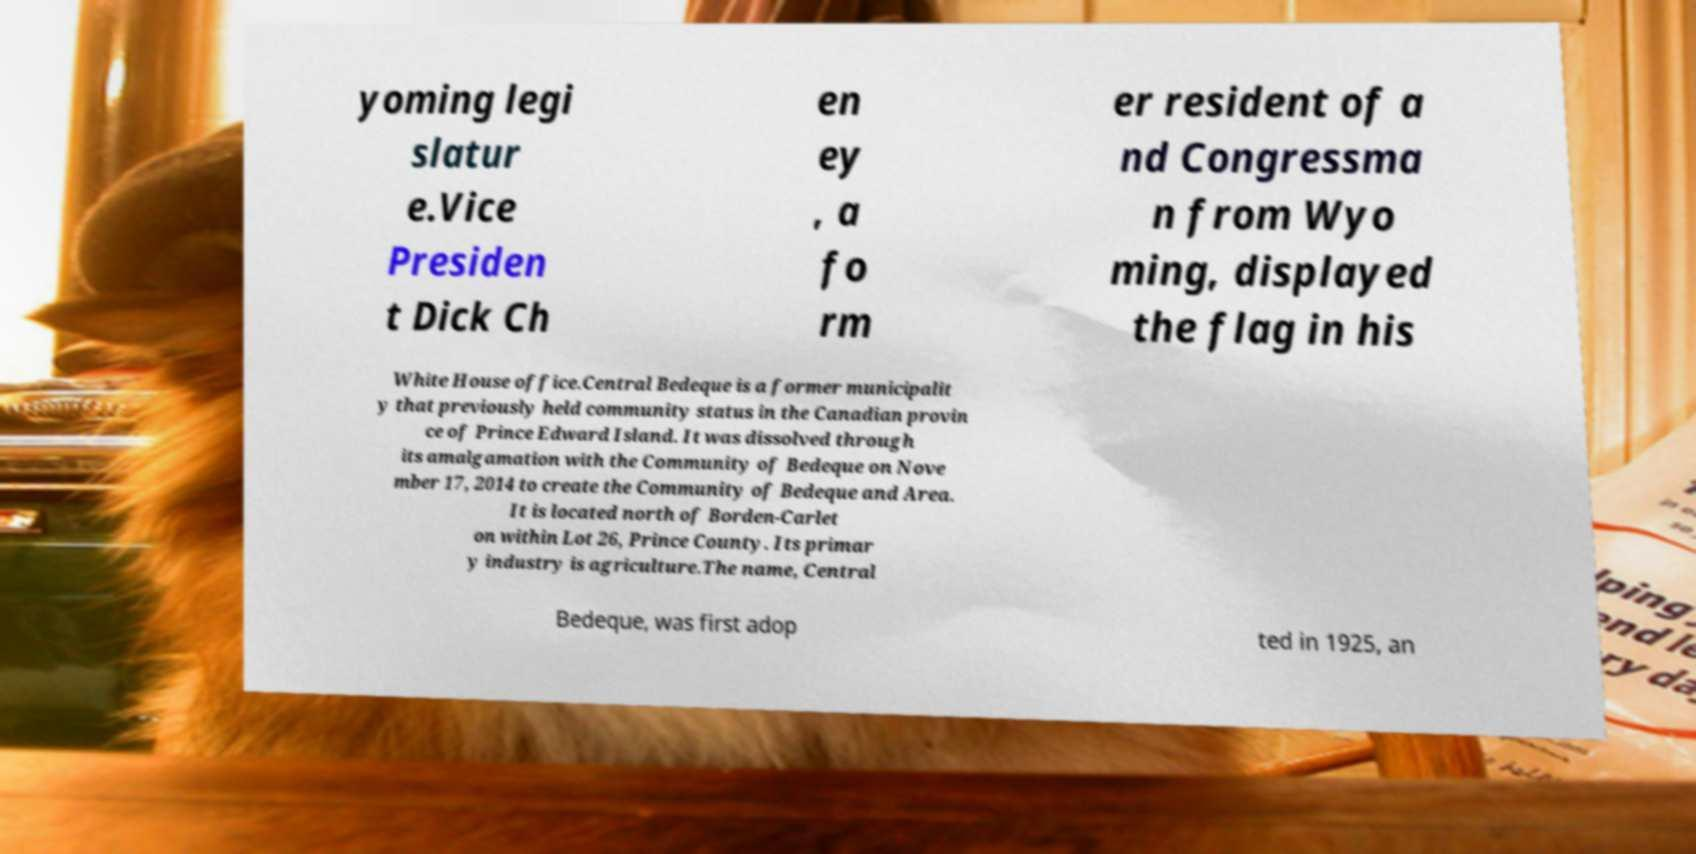For documentation purposes, I need the text within this image transcribed. Could you provide that? yoming legi slatur e.Vice Presiden t Dick Ch en ey , a fo rm er resident of a nd Congressma n from Wyo ming, displayed the flag in his White House office.Central Bedeque is a former municipalit y that previously held community status in the Canadian provin ce of Prince Edward Island. It was dissolved through its amalgamation with the Community of Bedeque on Nove mber 17, 2014 to create the Community of Bedeque and Area. It is located north of Borden-Carlet on within Lot 26, Prince County. Its primar y industry is agriculture.The name, Central Bedeque, was first adop ted in 1925, an 